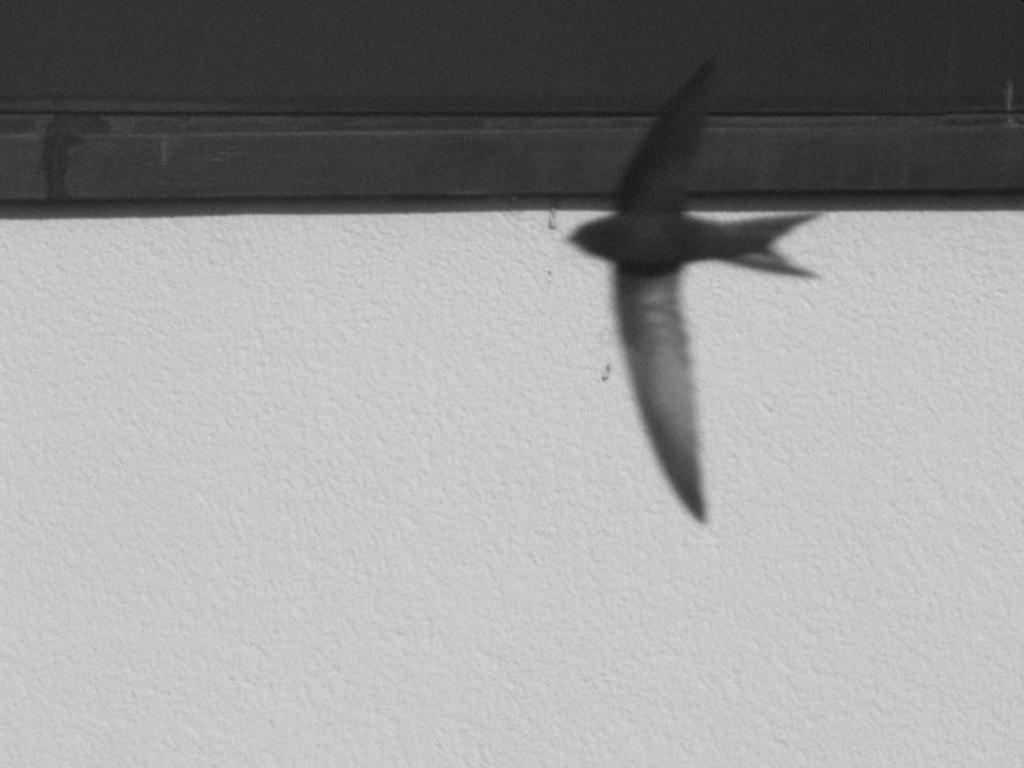What is the main subject of the image? There is a bird flying in the image. Can you describe the bird's action in the image? The bird is flying in the image. What else can be seen in the background of the image? There is an object on the wall in the background of the image. How many geese are flying alongside the bird in the image? There are no geese present in the image; only a single bird is flying. What type of finger can be seen interacting with the bird in the image? There is no finger present in the image; the bird is flying independently. 